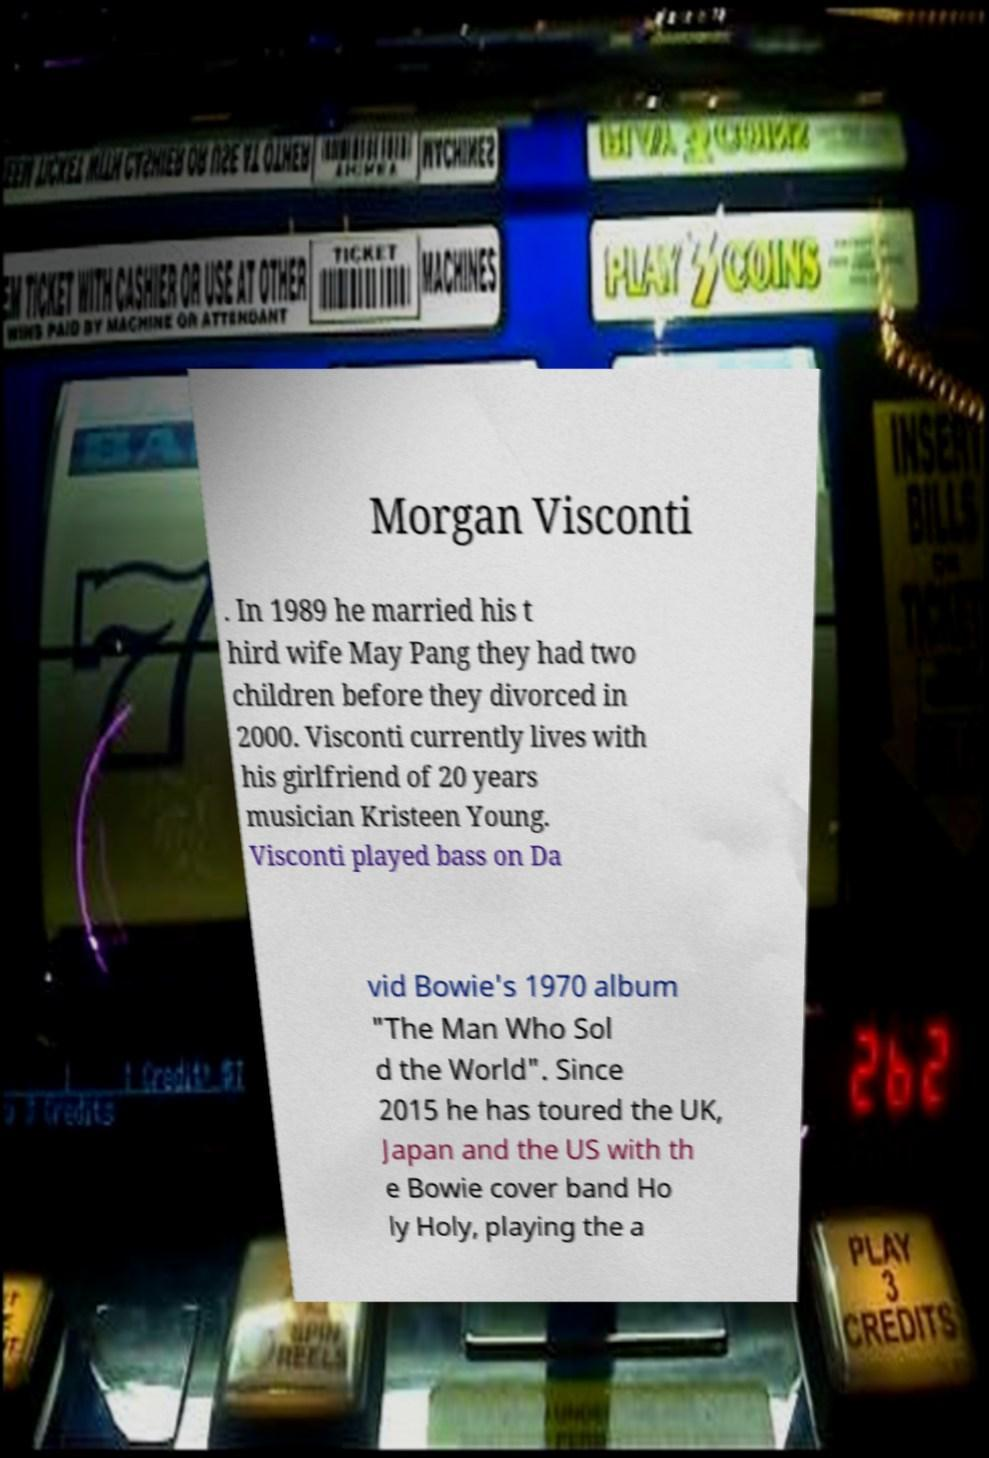Can you read and provide the text displayed in the image?This photo seems to have some interesting text. Can you extract and type it out for me? Morgan Visconti . In 1989 he married his t hird wife May Pang they had two children before they divorced in 2000. Visconti currently lives with his girlfriend of 20 years musician Kristeen Young. Visconti played bass on Da vid Bowie's 1970 album "The Man Who Sol d the World". Since 2015 he has toured the UK, Japan and the US with th e Bowie cover band Ho ly Holy, playing the a 